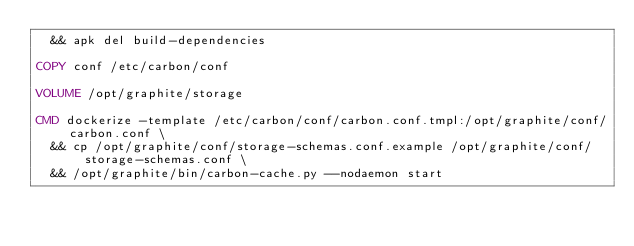<code> <loc_0><loc_0><loc_500><loc_500><_Dockerfile_>  && apk del build-dependencies

COPY conf /etc/carbon/conf

VOLUME /opt/graphite/storage

CMD dockerize -template /etc/carbon/conf/carbon.conf.tmpl:/opt/graphite/conf/carbon.conf \
  && cp /opt/graphite/conf/storage-schemas.conf.example /opt/graphite/conf/storage-schemas.conf \
  && /opt/graphite/bin/carbon-cache.py --nodaemon start
</code> 